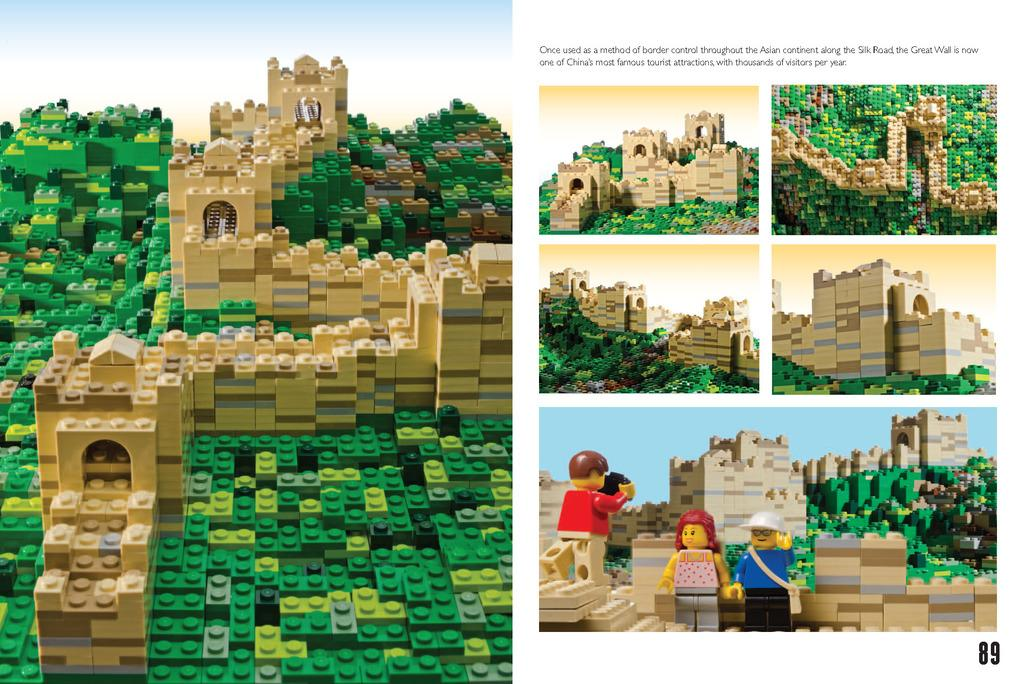What type of objects are present in the image? There are building blocks and toys in the image. Can you describe the text visible in the image? Unfortunately, the specific text cannot be described without more information about the image. What might the toys be used for? The toys in the image might be used for play or entertainment. What type of treatment is being administered to the building blocks in the image? There is no treatment being administered to the building blocks in the image, as they are inanimate objects and do not require medical attention. 